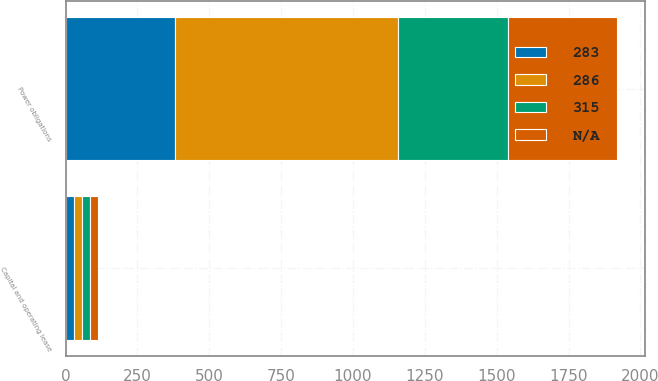<chart> <loc_0><loc_0><loc_500><loc_500><stacked_bar_chart><ecel><fcel>Capital and operating lease<fcel>Power obligations<nl><fcel>nan<fcel>28<fcel>380<nl><fcel>283<fcel>28<fcel>382<nl><fcel>315<fcel>25<fcel>383<nl><fcel>286<fcel>31<fcel>775<nl></chart> 